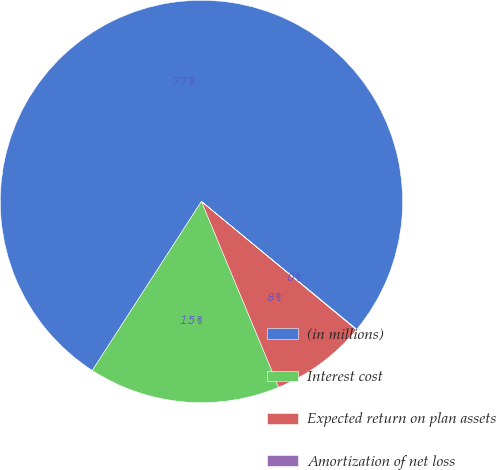Convert chart to OTSL. <chart><loc_0><loc_0><loc_500><loc_500><pie_chart><fcel>(in millions)<fcel>Interest cost<fcel>Expected return on plan assets<fcel>Amortization of net loss<nl><fcel>76.84%<fcel>15.4%<fcel>7.72%<fcel>0.04%<nl></chart> 